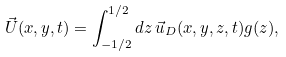<formula> <loc_0><loc_0><loc_500><loc_500>\vec { U } ( x , y , t ) = \int _ { - 1 / 2 } ^ { 1 / 2 } d z \, \vec { u } _ { D } ( x , y , z , t ) g ( z ) ,</formula> 